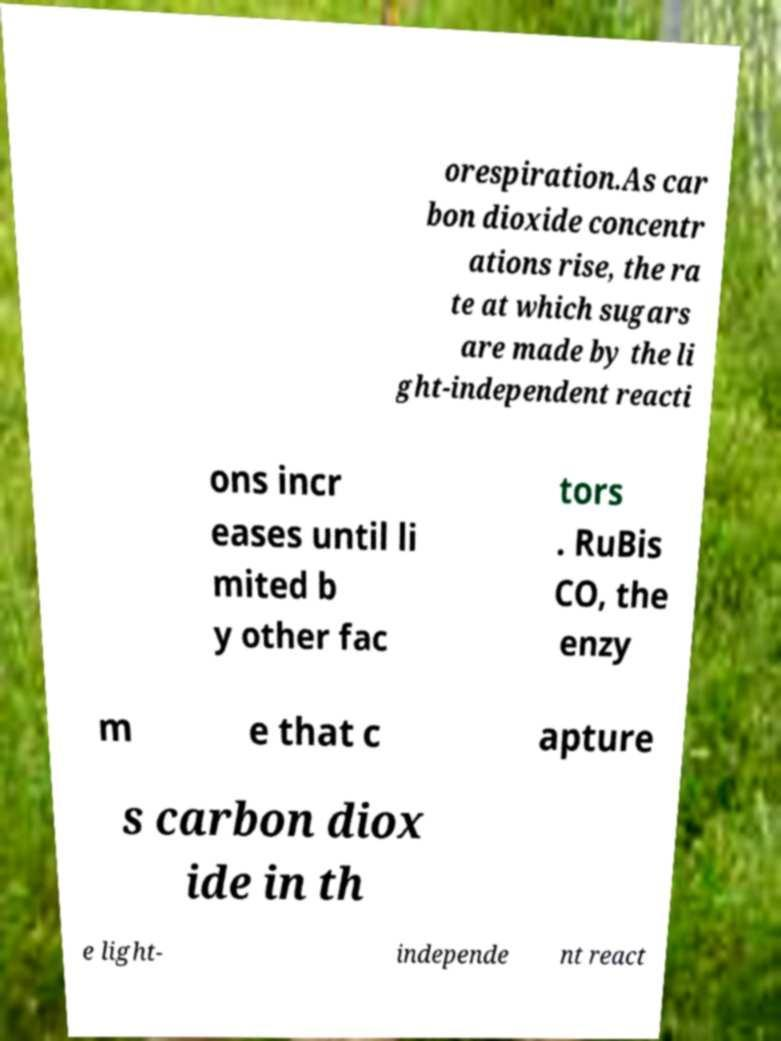Please read and relay the text visible in this image. What does it say? orespiration.As car bon dioxide concentr ations rise, the ra te at which sugars are made by the li ght-independent reacti ons incr eases until li mited b y other fac tors . RuBis CO, the enzy m e that c apture s carbon diox ide in th e light- independe nt react 